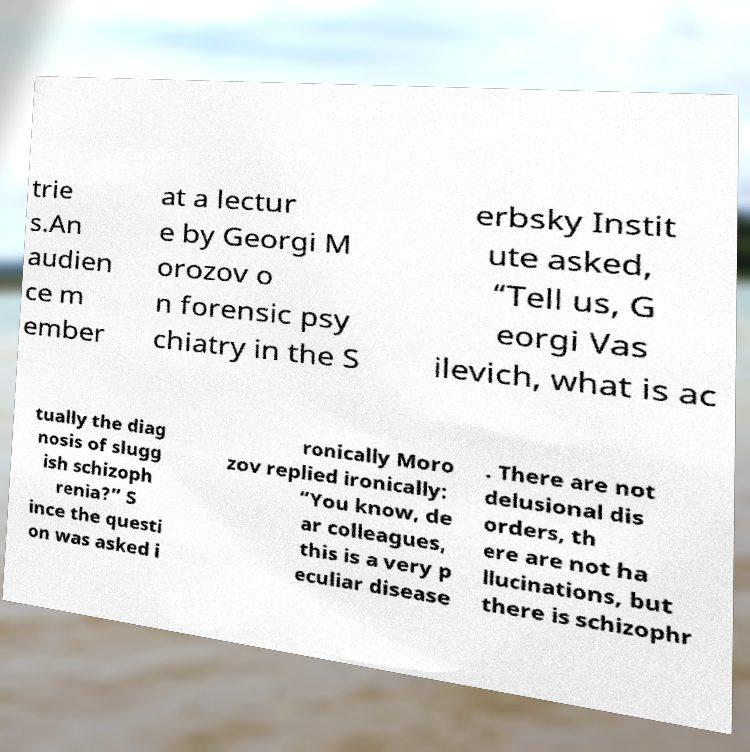Please read and relay the text visible in this image. What does it say? trie s.An audien ce m ember at a lectur e by Georgi M orozov o n forensic psy chiatry in the S erbsky Instit ute asked, “Tell us, G eorgi Vas ilevich, what is ac tually the diag nosis of slugg ish schizoph renia?” S ince the questi on was asked i ronically Moro zov replied ironically: “You know, de ar colleagues, this is a very p eculiar disease . There are not delusional dis orders, th ere are not ha llucinations, but there is schizophr 